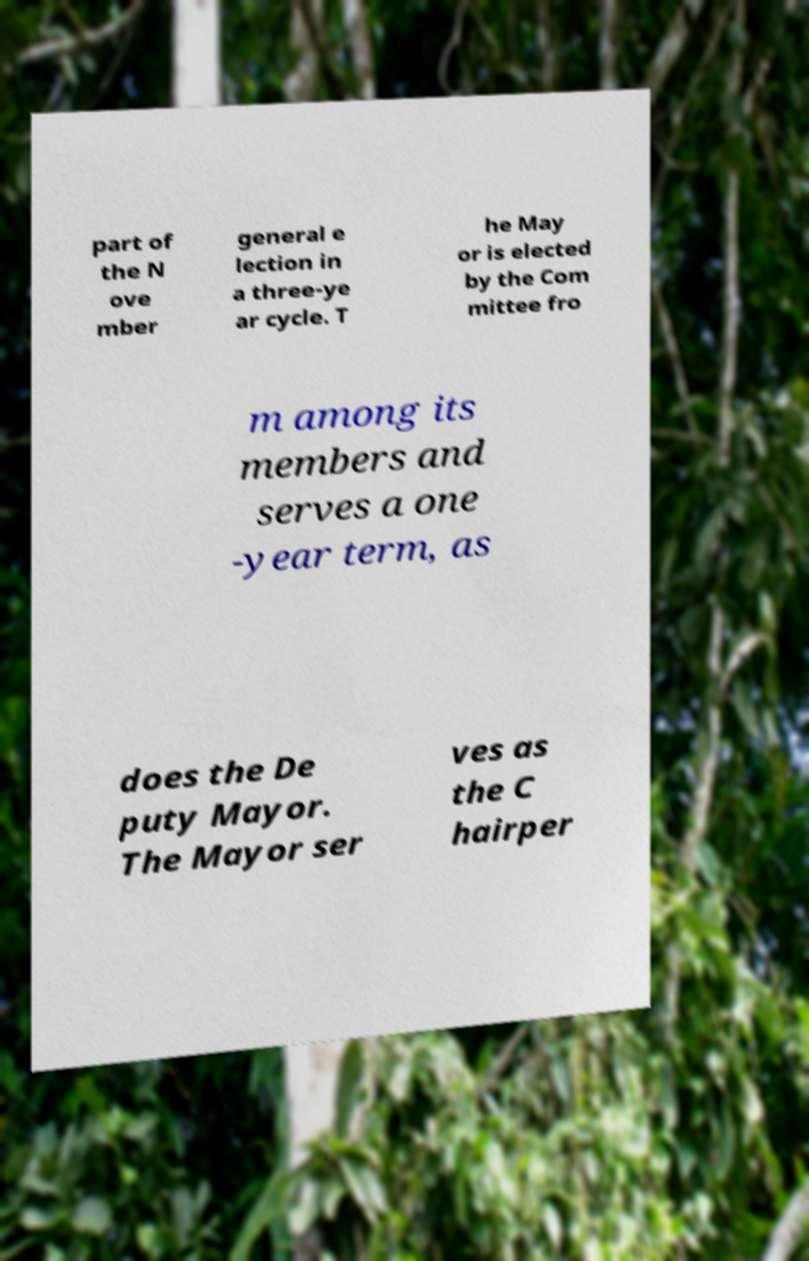I need the written content from this picture converted into text. Can you do that? part of the N ove mber general e lection in a three-ye ar cycle. T he May or is elected by the Com mittee fro m among its members and serves a one -year term, as does the De puty Mayor. The Mayor ser ves as the C hairper 